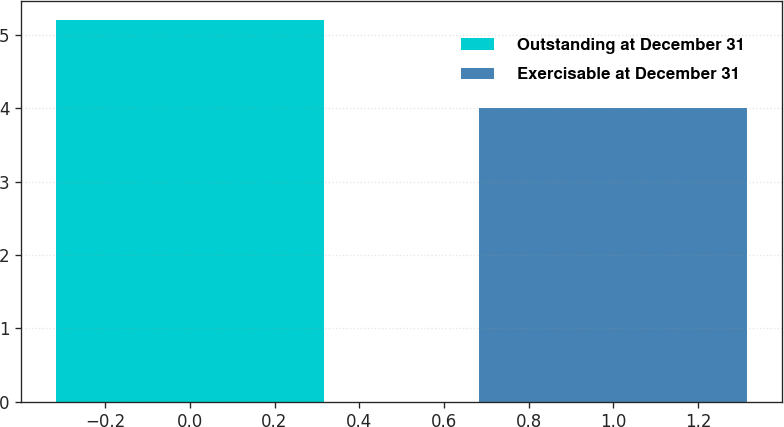<chart> <loc_0><loc_0><loc_500><loc_500><bar_chart><fcel>Outstanding at December 31<fcel>Exercisable at December 31<nl><fcel>5.2<fcel>4<nl></chart> 